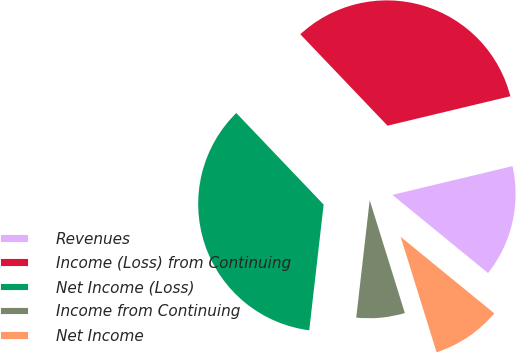Convert chart to OTSL. <chart><loc_0><loc_0><loc_500><loc_500><pie_chart><fcel>Revenues<fcel>Income (Loss) from Continuing<fcel>Net Income (Loss)<fcel>Income from Continuing<fcel>Net Income<nl><fcel>14.65%<fcel>33.38%<fcel>36.06%<fcel>6.62%<fcel>9.29%<nl></chart> 